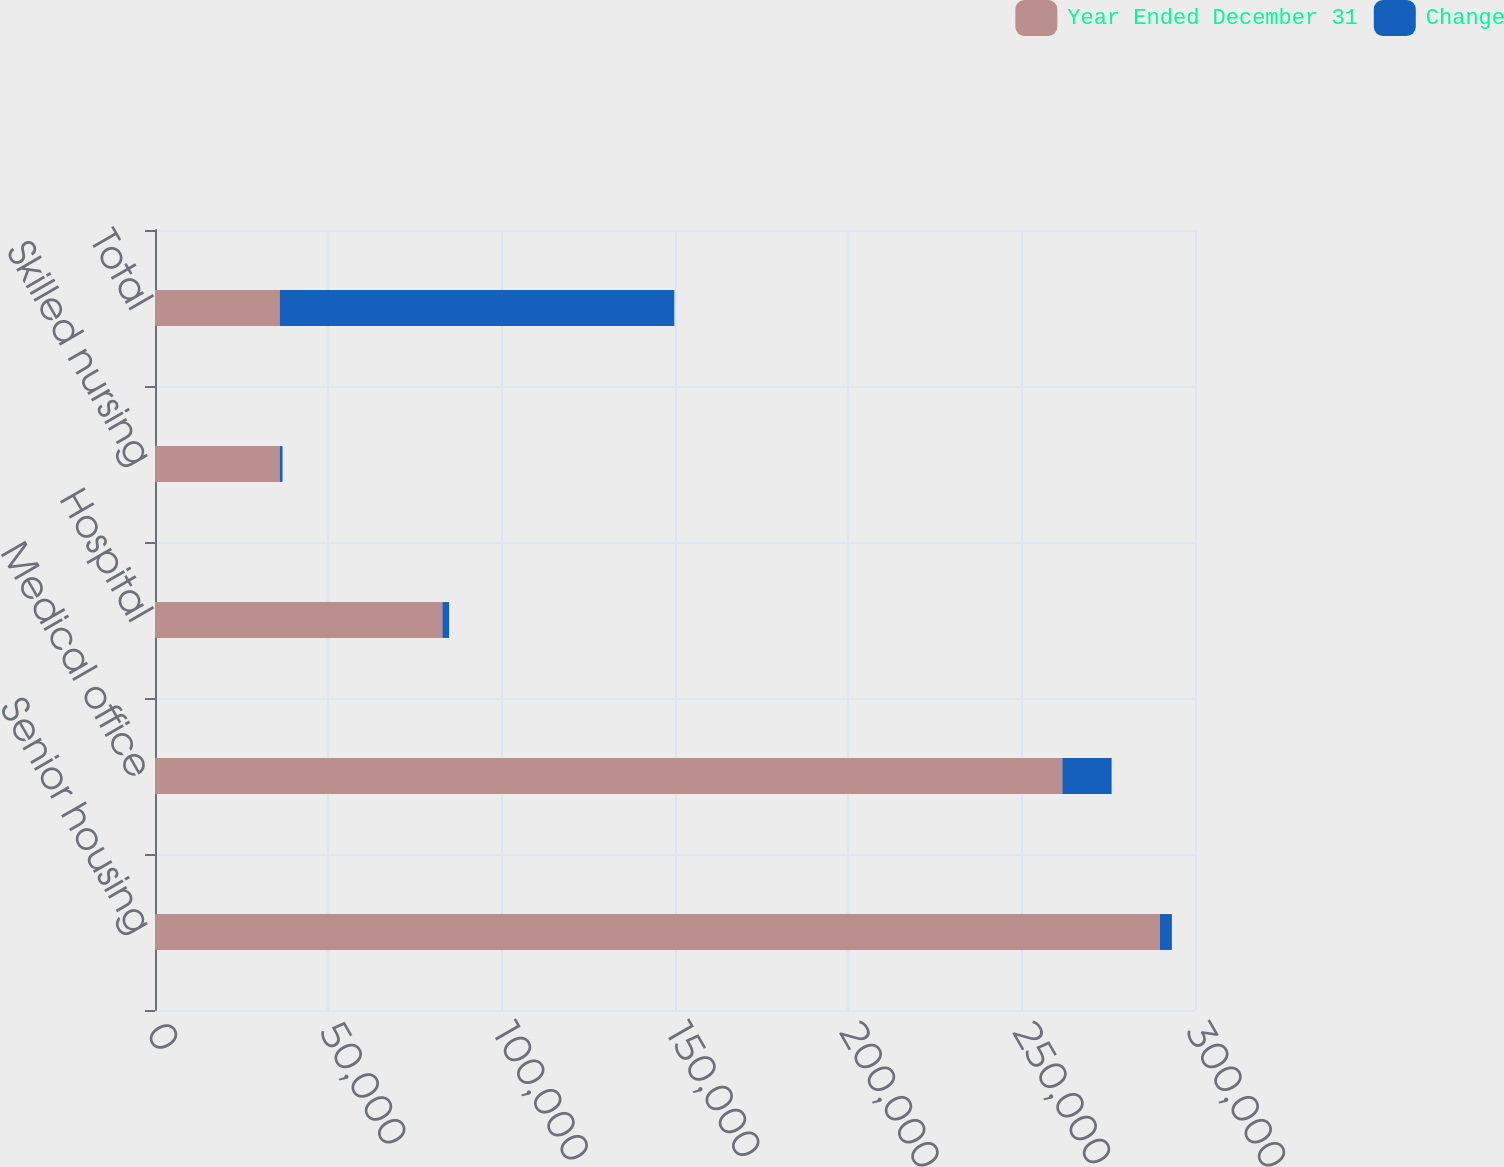Convert chart. <chart><loc_0><loc_0><loc_500><loc_500><stacked_bar_chart><ecel><fcel>Senior housing<fcel>Medical office<fcel>Hospital<fcel>Skilled nursing<fcel>Total<nl><fcel>Year Ended December 31<fcel>289876<fcel>261732<fcel>82894<fcel>35982<fcel>35982<nl><fcel>Change<fcel>3455<fcel>14219<fcel>1934<fcel>810<fcel>113825<nl></chart> 